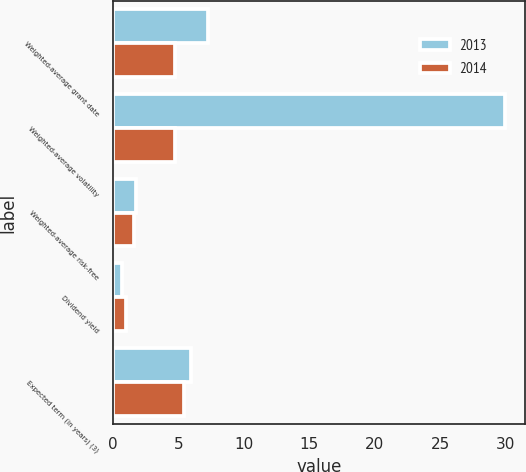Convert chart to OTSL. <chart><loc_0><loc_0><loc_500><loc_500><stacked_bar_chart><ecel><fcel>Weighted-average grant date<fcel>Weighted-average volatility<fcel>Weighted-average risk-free<fcel>Dividend yield<fcel>Expected term (in years) (3)<nl><fcel>2013<fcel>7.23<fcel>30<fcel>1.77<fcel>0.7<fcel>6<nl><fcel>2014<fcel>4.75<fcel>4.75<fcel>1.58<fcel>1<fcel>5.4<nl></chart> 